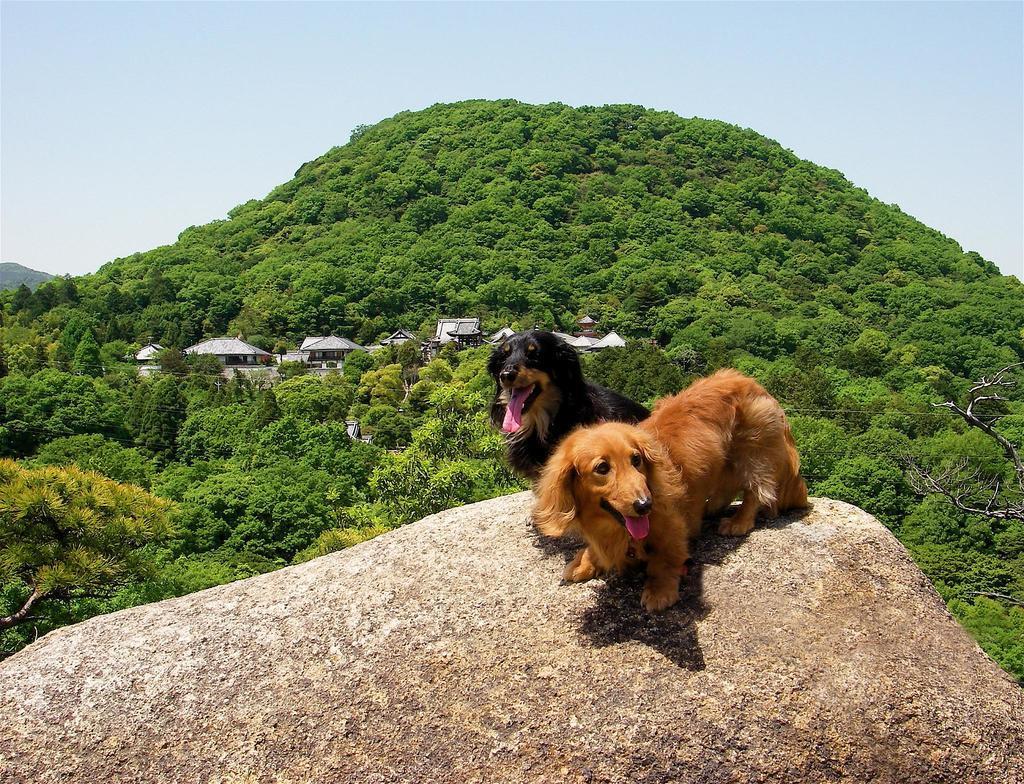Describe this image in one or two sentences. In this image I can see a huge rock which is cream and brown in color and I can see two dogs which are brown and black in color on the rock. In the background I can see few mountains, few trees on the mountains, few buildings and I can see the sky. 